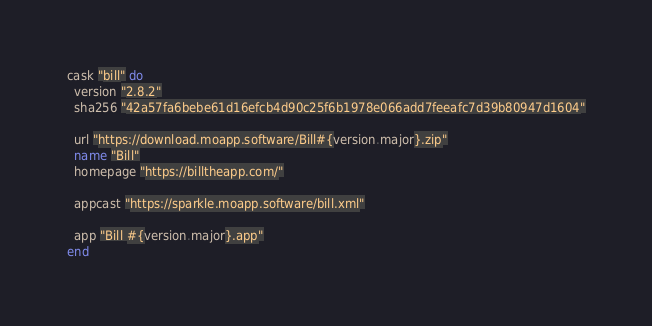<code> <loc_0><loc_0><loc_500><loc_500><_Ruby_>cask "bill" do
  version "2.8.2"
  sha256 "42a57fa6bebe61d16efcb4d90c25f6b1978e066add7feeafc7d39b80947d1604"

  url "https://download.moapp.software/Bill#{version.major}.zip"
  name "Bill"
  homepage "https://billtheapp.com/"

  appcast "https://sparkle.moapp.software/bill.xml"

  app "Bill #{version.major}.app"
end
</code> 